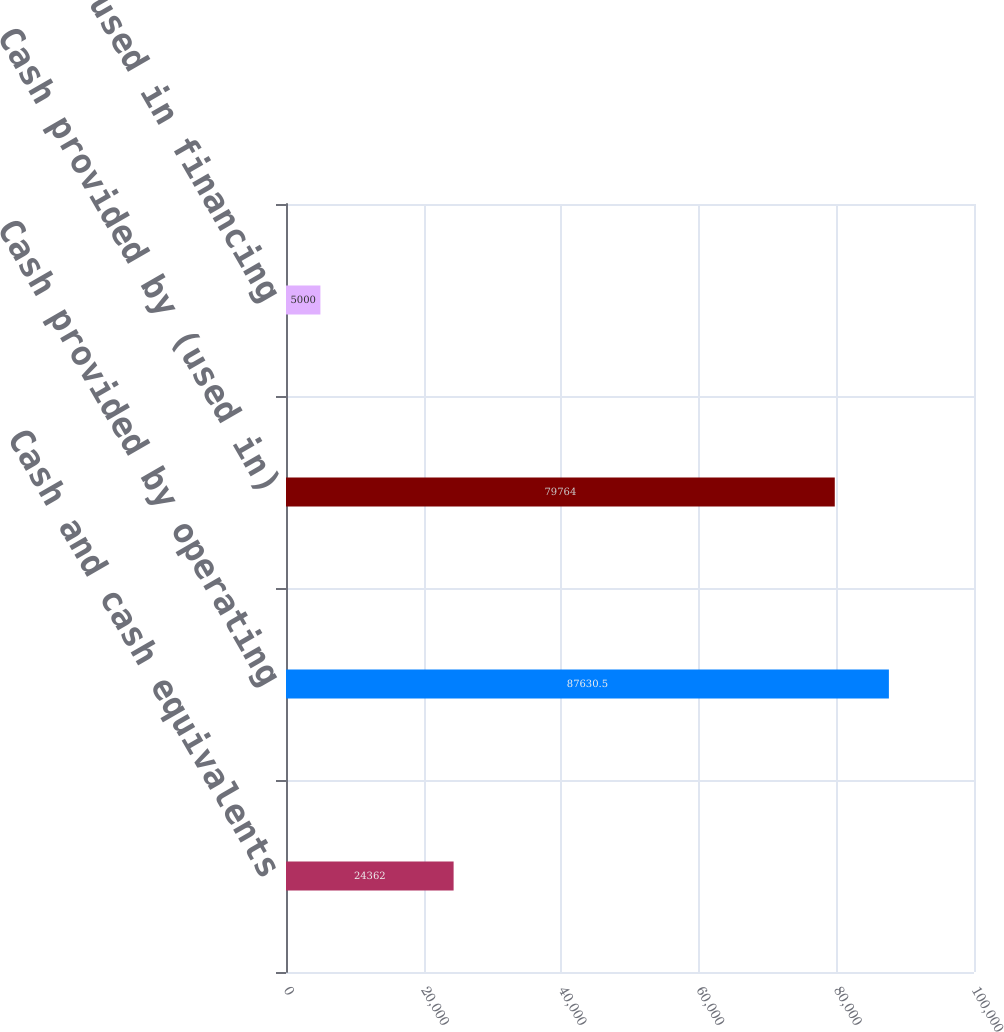Convert chart to OTSL. <chart><loc_0><loc_0><loc_500><loc_500><bar_chart><fcel>Cash and cash equivalents<fcel>Cash provided by operating<fcel>Cash provided by (used in)<fcel>Cash used in financing<nl><fcel>24362<fcel>87630.5<fcel>79764<fcel>5000<nl></chart> 